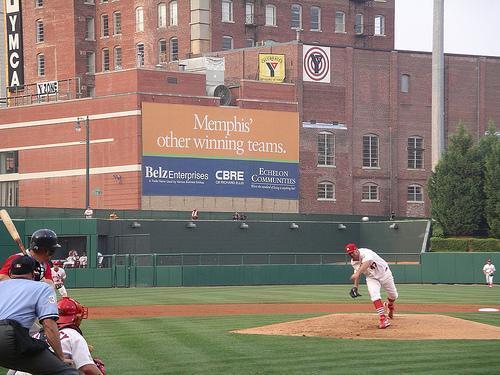How many pitchers are there?
Give a very brief answer. 1. 